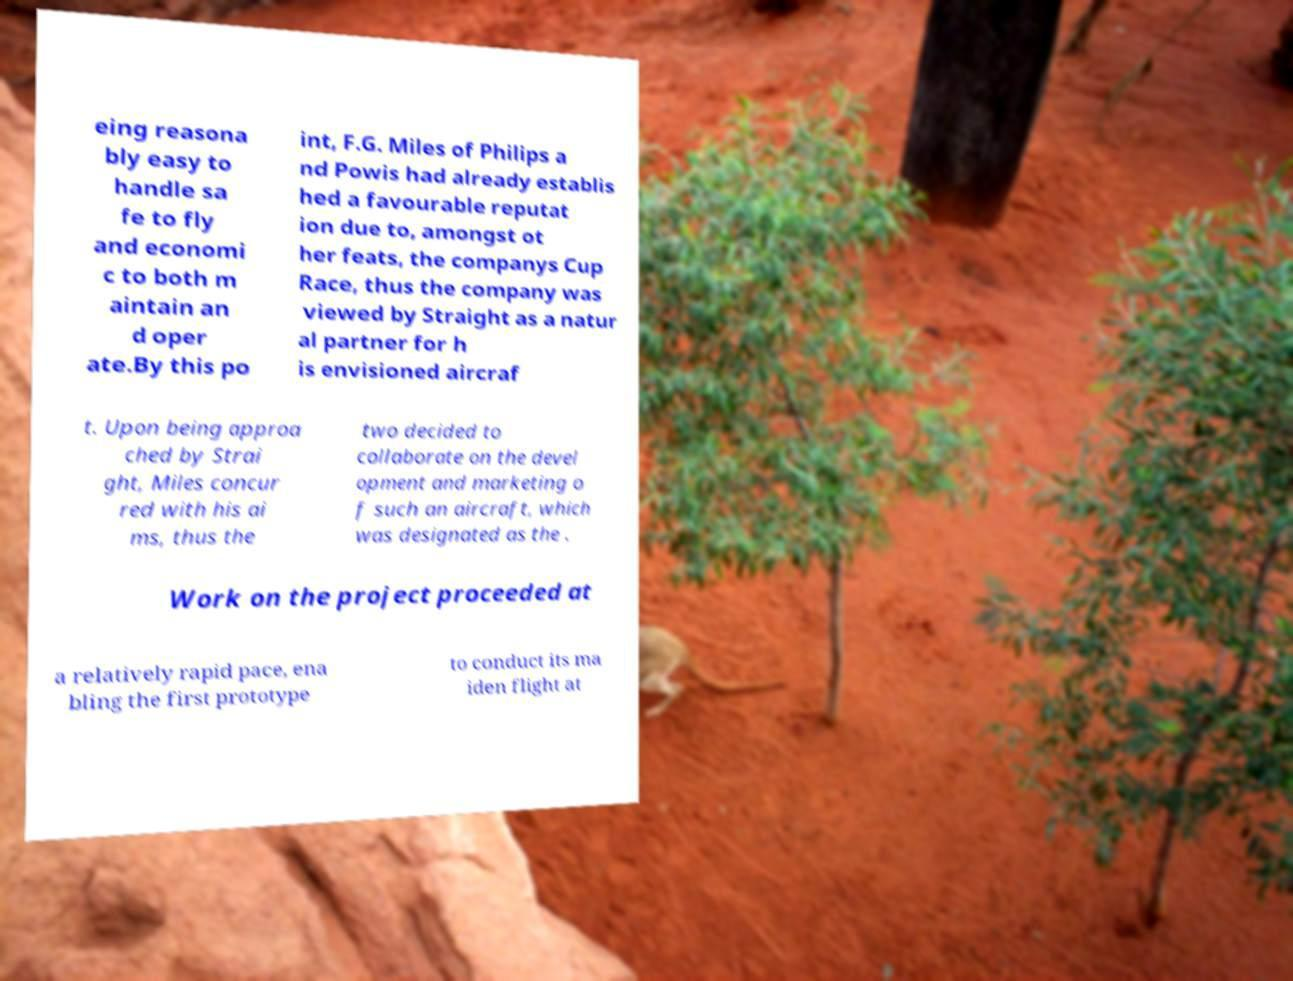Can you read and provide the text displayed in the image?This photo seems to have some interesting text. Can you extract and type it out for me? eing reasona bly easy to handle sa fe to fly and economi c to both m aintain an d oper ate.By this po int, F.G. Miles of Philips a nd Powis had already establis hed a favourable reputat ion due to, amongst ot her feats, the companys Cup Race, thus the company was viewed by Straight as a natur al partner for h is envisioned aircraf t. Upon being approa ched by Strai ght, Miles concur red with his ai ms, thus the two decided to collaborate on the devel opment and marketing o f such an aircraft, which was designated as the . Work on the project proceeded at a relatively rapid pace, ena bling the first prototype to conduct its ma iden flight at 